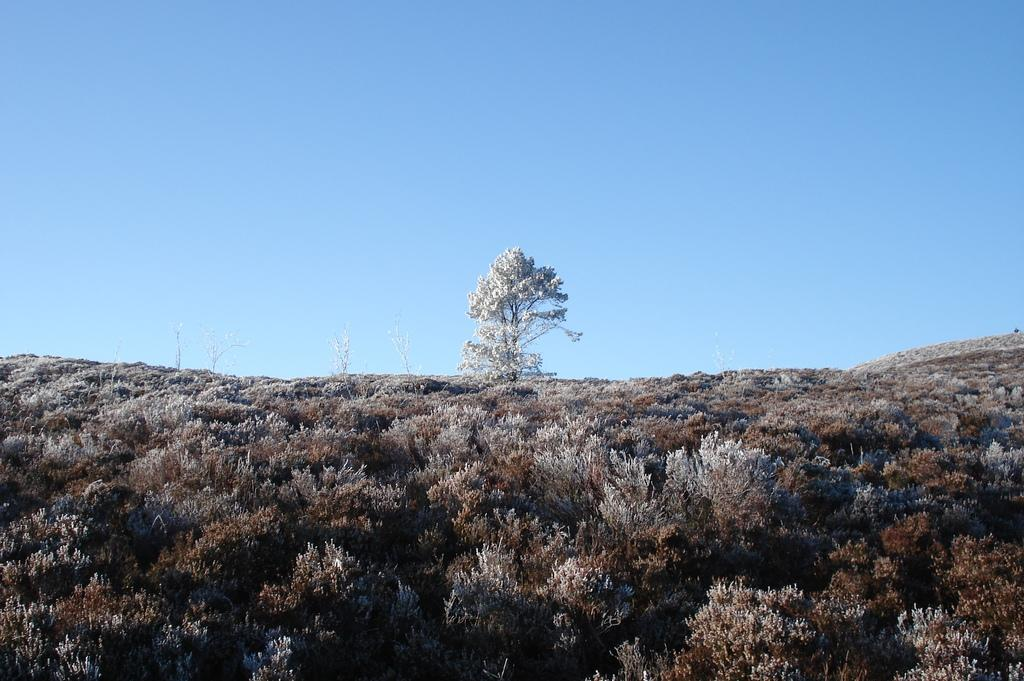What type of trees are in the image? There are dry trees in the image. What colors are the dry trees? The dry trees are in brown and white color. What can be seen in the sky in the image? The sky is in blue and white color. What type of work is being done on the car in the image? There is no car present in the image; it only features dry trees and a blue and white sky. 